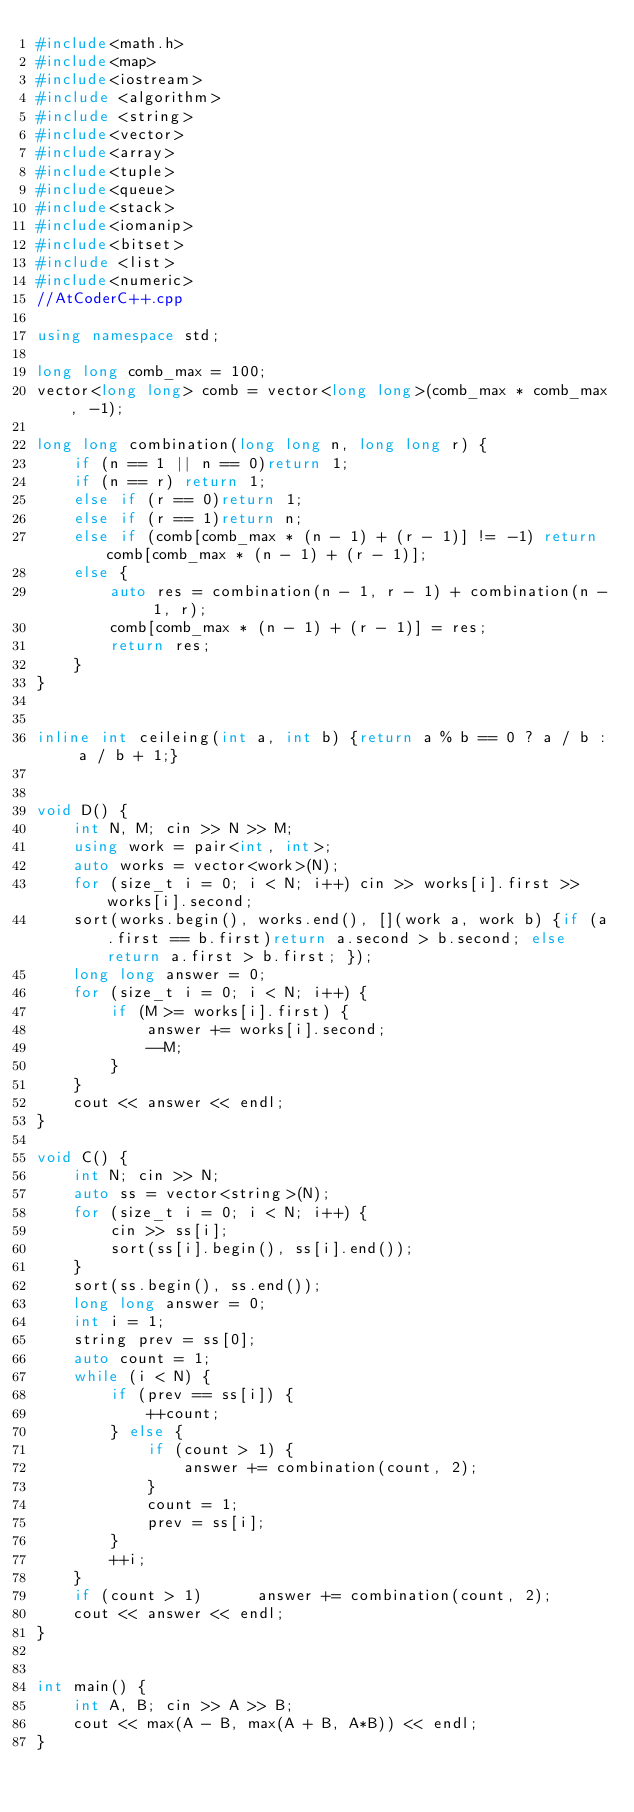<code> <loc_0><loc_0><loc_500><loc_500><_C++_>#include<math.h>
#include<map>
#include<iostream>
#include <algorithm>
#include <string>
#include<vector>
#include<array>
#include<tuple>
#include<queue>
#include<stack>
#include<iomanip>
#include<bitset>
#include <list>
#include<numeric>
//AtCoderC++.cpp

using namespace std;

long long comb_max = 100;
vector<long long> comb = vector<long long>(comb_max * comb_max, -1);

long long combination(long long n, long long r) {
	if (n == 1 || n == 0)return 1;
	if (n == r)	return 1;
	else if (r == 0)return 1;
	else if (r == 1)return n;
	else if (comb[comb_max * (n - 1) + (r - 1)] != -1) return comb[comb_max * (n - 1) + (r - 1)];
	else {
		auto res = combination(n - 1, r - 1) + combination(n - 1, r);
		comb[comb_max * (n - 1) + (r - 1)] = res;
		return res;
	}
}


inline int ceileing(int a, int b) {return a % b == 0 ? a / b : a / b + 1;}


void D() {
	int N, M; cin >> N >> M;
	using work = pair<int, int>;
	auto works = vector<work>(N);
	for (size_t i = 0; i < N; i++) cin >> works[i].first >> works[i].second;
	sort(works.begin(), works.end(), [](work a, work b) {if (a.first == b.first)return a.second > b.second; else return a.first > b.first; });
	long long answer = 0;
	for (size_t i = 0; i < N; i++) {
		if (M >= works[i].first) {
			answer += works[i].second;
			--M;
		}
	}
	cout << answer << endl;
}

void C() {
	int N; cin >> N;
	auto ss = vector<string>(N);
	for (size_t i = 0; i < N; i++) {
		cin >> ss[i];
		sort(ss[i].begin(), ss[i].end());
	}
	sort(ss.begin(), ss.end());
	long long answer = 0;
	int i = 1;
	string prev = ss[0];
	auto count = 1;
	while (i < N) {
		if (prev == ss[i]) {
			++count;
		} else {
			if (count > 1) {
				answer += combination(count, 2);
			}
			count = 1;
			prev = ss[i];
		}
		++i;
	}
	if (count > 1) 		answer += combination(count, 2);
	cout << answer << endl;
}


int main() {
	int A, B; cin >> A >> B;
	cout << max(A - B, max(A + B, A*B)) << endl;
}</code> 